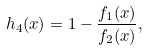Convert formula to latex. <formula><loc_0><loc_0><loc_500><loc_500>h _ { 4 } ( x ) = 1 - \frac { f _ { 1 } ( x ) } { f _ { 2 } ( x ) } ,</formula> 